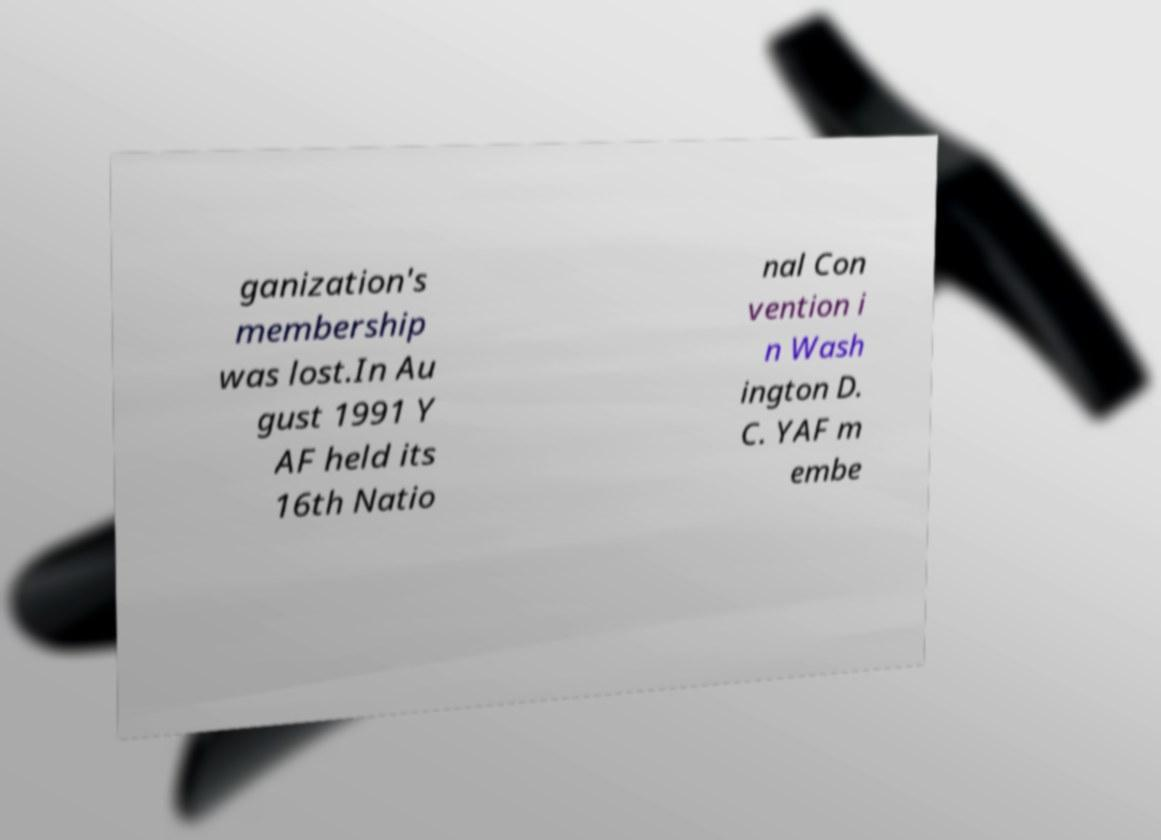I need the written content from this picture converted into text. Can you do that? ganization's membership was lost.In Au gust 1991 Y AF held its 16th Natio nal Con vention i n Wash ington D. C. YAF m embe 